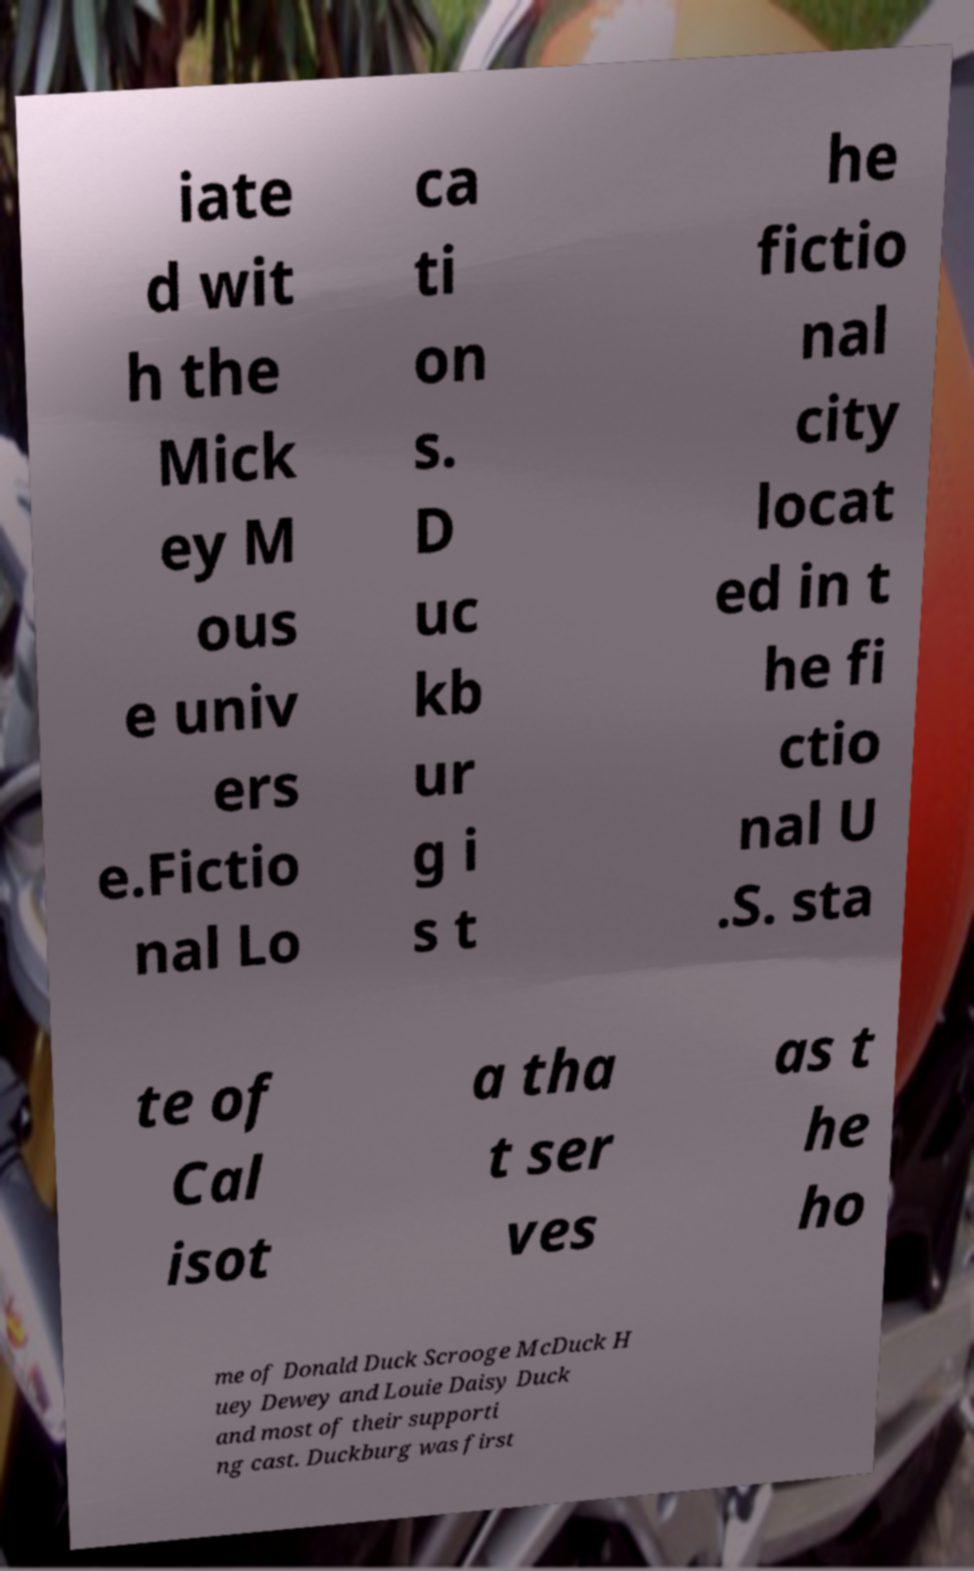Please identify and transcribe the text found in this image. iate d wit h the Mick ey M ous e univ ers e.Fictio nal Lo ca ti on s. D uc kb ur g i s t he fictio nal city locat ed in t he fi ctio nal U .S. sta te of Cal isot a tha t ser ves as t he ho me of Donald Duck Scrooge McDuck H uey Dewey and Louie Daisy Duck and most of their supporti ng cast. Duckburg was first 